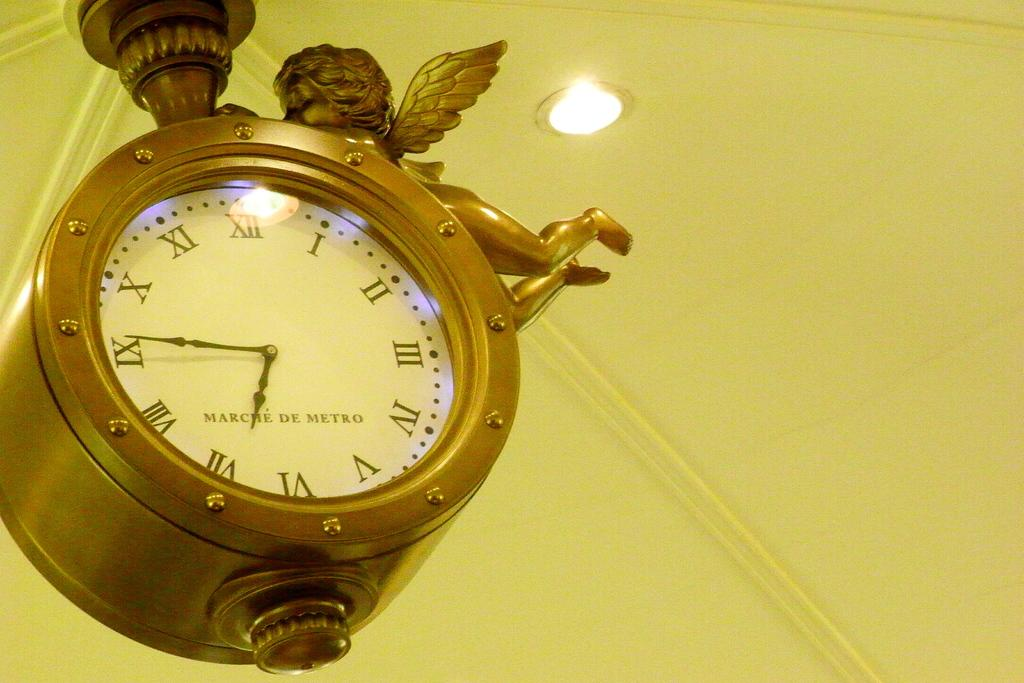Provide a one-sentence caption for the provided image. The gold clock hanging on the ceiling reads 6:45. 